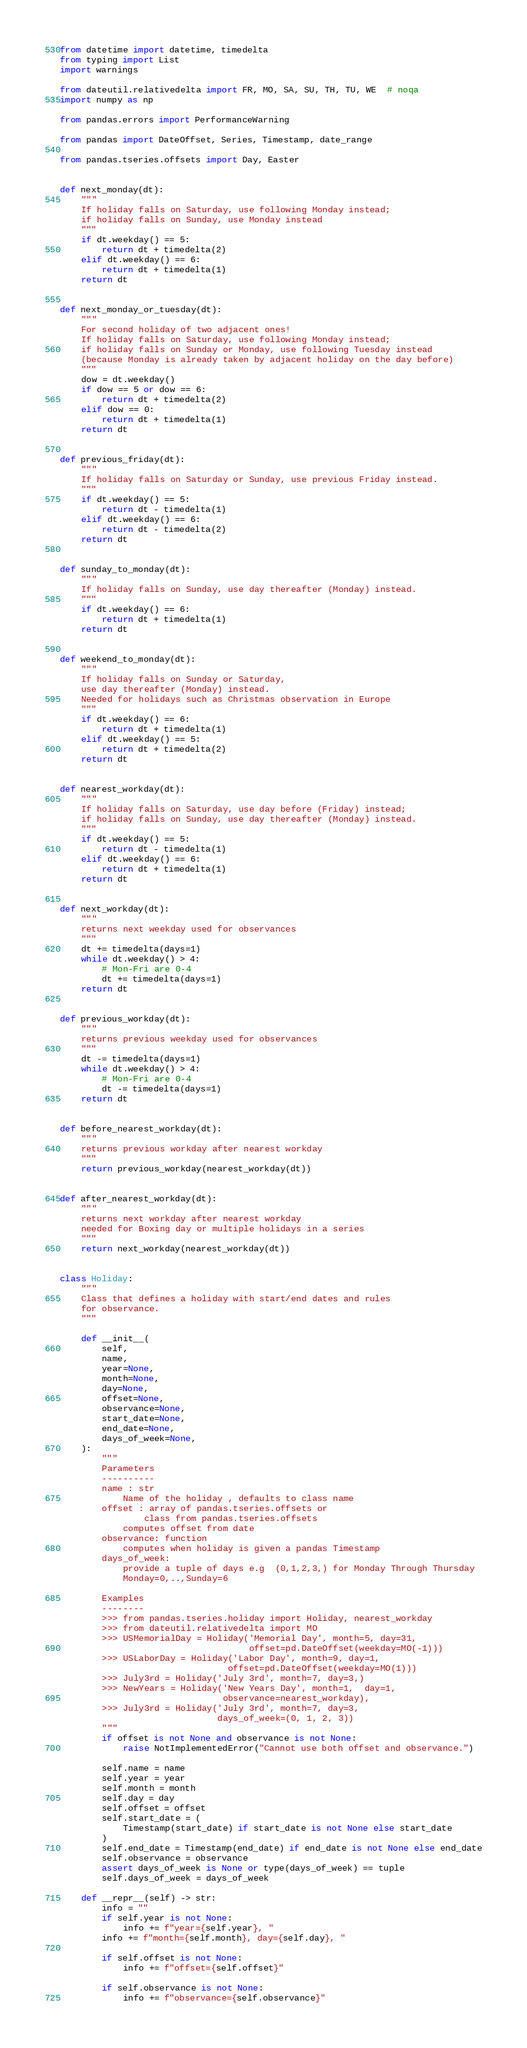Convert code to text. <code><loc_0><loc_0><loc_500><loc_500><_Python_>from datetime import datetime, timedelta
from typing import List
import warnings

from dateutil.relativedelta import FR, MO, SA, SU, TH, TU, WE  # noqa
import numpy as np

from pandas.errors import PerformanceWarning

from pandas import DateOffset, Series, Timestamp, date_range

from pandas.tseries.offsets import Day, Easter


def next_monday(dt):
    """
    If holiday falls on Saturday, use following Monday instead;
    if holiday falls on Sunday, use Monday instead
    """
    if dt.weekday() == 5:
        return dt + timedelta(2)
    elif dt.weekday() == 6:
        return dt + timedelta(1)
    return dt


def next_monday_or_tuesday(dt):
    """
    For second holiday of two adjacent ones!
    If holiday falls on Saturday, use following Monday instead;
    if holiday falls on Sunday or Monday, use following Tuesday instead
    (because Monday is already taken by adjacent holiday on the day before)
    """
    dow = dt.weekday()
    if dow == 5 or dow == 6:
        return dt + timedelta(2)
    elif dow == 0:
        return dt + timedelta(1)
    return dt


def previous_friday(dt):
    """
    If holiday falls on Saturday or Sunday, use previous Friday instead.
    """
    if dt.weekday() == 5:
        return dt - timedelta(1)
    elif dt.weekday() == 6:
        return dt - timedelta(2)
    return dt


def sunday_to_monday(dt):
    """
    If holiday falls on Sunday, use day thereafter (Monday) instead.
    """
    if dt.weekday() == 6:
        return dt + timedelta(1)
    return dt


def weekend_to_monday(dt):
    """
    If holiday falls on Sunday or Saturday,
    use day thereafter (Monday) instead.
    Needed for holidays such as Christmas observation in Europe
    """
    if dt.weekday() == 6:
        return dt + timedelta(1)
    elif dt.weekday() == 5:
        return dt + timedelta(2)
    return dt


def nearest_workday(dt):
    """
    If holiday falls on Saturday, use day before (Friday) instead;
    if holiday falls on Sunday, use day thereafter (Monday) instead.
    """
    if dt.weekday() == 5:
        return dt - timedelta(1)
    elif dt.weekday() == 6:
        return dt + timedelta(1)
    return dt


def next_workday(dt):
    """
    returns next weekday used for observances
    """
    dt += timedelta(days=1)
    while dt.weekday() > 4:
        # Mon-Fri are 0-4
        dt += timedelta(days=1)
    return dt


def previous_workday(dt):
    """
    returns previous weekday used for observances
    """
    dt -= timedelta(days=1)
    while dt.weekday() > 4:
        # Mon-Fri are 0-4
        dt -= timedelta(days=1)
    return dt


def before_nearest_workday(dt):
    """
    returns previous workday after nearest workday
    """
    return previous_workday(nearest_workday(dt))


def after_nearest_workday(dt):
    """
    returns next workday after nearest workday
    needed for Boxing day or multiple holidays in a series
    """
    return next_workday(nearest_workday(dt))


class Holiday:
    """
    Class that defines a holiday with start/end dates and rules
    for observance.
    """

    def __init__(
        self,
        name,
        year=None,
        month=None,
        day=None,
        offset=None,
        observance=None,
        start_date=None,
        end_date=None,
        days_of_week=None,
    ):
        """
        Parameters
        ----------
        name : str
            Name of the holiday , defaults to class name
        offset : array of pandas.tseries.offsets or
                class from pandas.tseries.offsets
            computes offset from date
        observance: function
            computes when holiday is given a pandas Timestamp
        days_of_week:
            provide a tuple of days e.g  (0,1,2,3,) for Monday Through Thursday
            Monday=0,..,Sunday=6

        Examples
        --------
        >>> from pandas.tseries.holiday import Holiday, nearest_workday
        >>> from dateutil.relativedelta import MO
        >>> USMemorialDay = Holiday('Memorial Day', month=5, day=31,
                                    offset=pd.DateOffset(weekday=MO(-1)))
        >>> USLaborDay = Holiday('Labor Day', month=9, day=1,
                                offset=pd.DateOffset(weekday=MO(1)))
        >>> July3rd = Holiday('July 3rd', month=7, day=3,)
        >>> NewYears = Holiday('New Years Day', month=1,  day=1,
                               observance=nearest_workday),
        >>> July3rd = Holiday('July 3rd', month=7, day=3,
                              days_of_week=(0, 1, 2, 3))
        """
        if offset is not None and observance is not None:
            raise NotImplementedError("Cannot use both offset and observance.")

        self.name = name
        self.year = year
        self.month = month
        self.day = day
        self.offset = offset
        self.start_date = (
            Timestamp(start_date) if start_date is not None else start_date
        )
        self.end_date = Timestamp(end_date) if end_date is not None else end_date
        self.observance = observance
        assert days_of_week is None or type(days_of_week) == tuple
        self.days_of_week = days_of_week

    def __repr__(self) -> str:
        info = ""
        if self.year is not None:
            info += f"year={self.year}, "
        info += f"month={self.month}, day={self.day}, "

        if self.offset is not None:
            info += f"offset={self.offset}"

        if self.observance is not None:
            info += f"observance={self.observance}"
</code> 